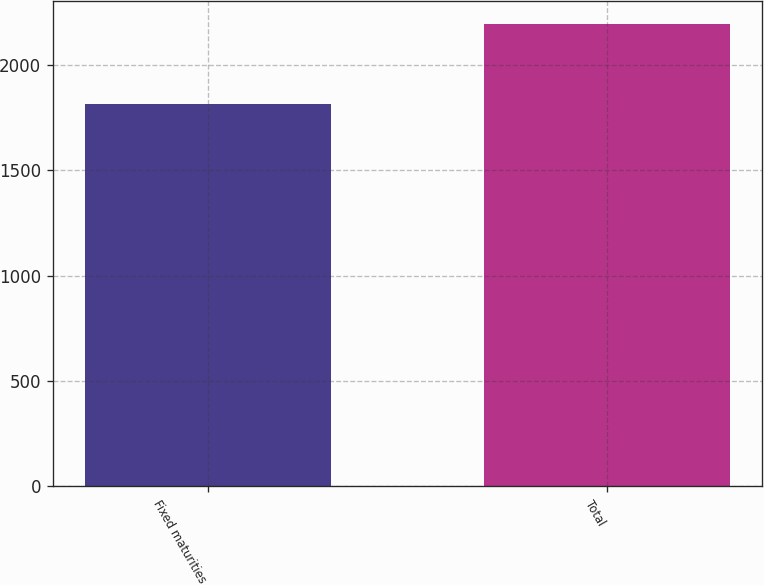<chart> <loc_0><loc_0><loc_500><loc_500><bar_chart><fcel>Fixed maturities<fcel>Total<nl><fcel>1813<fcel>2195<nl></chart> 